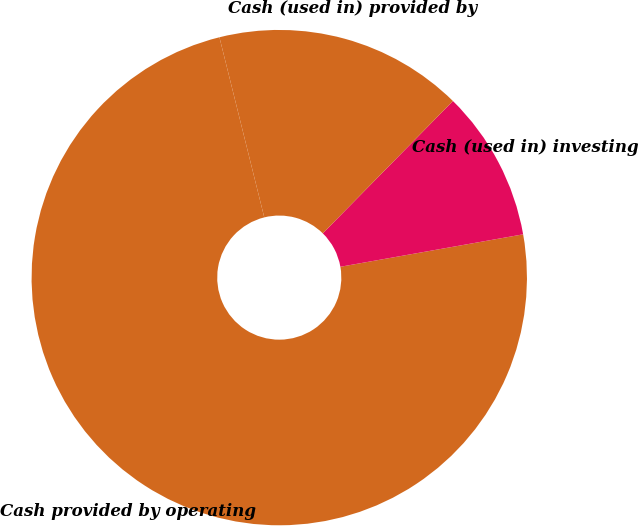Convert chart. <chart><loc_0><loc_0><loc_500><loc_500><pie_chart><fcel>Cash provided by operating<fcel>Cash (used in) investing<fcel>Cash (used in) provided by<nl><fcel>73.92%<fcel>9.84%<fcel>16.25%<nl></chart> 